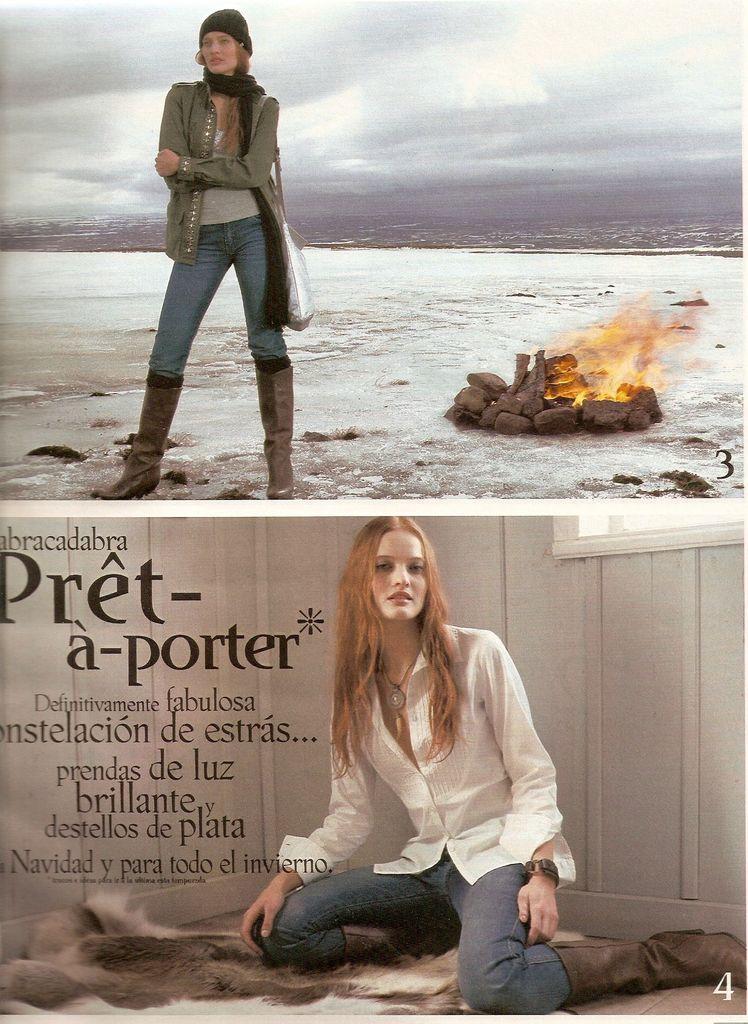Describe this image in one or two sentences. Here a woman is sitting, here a woman is standing, here there are stones, this is fire, this is sky. 